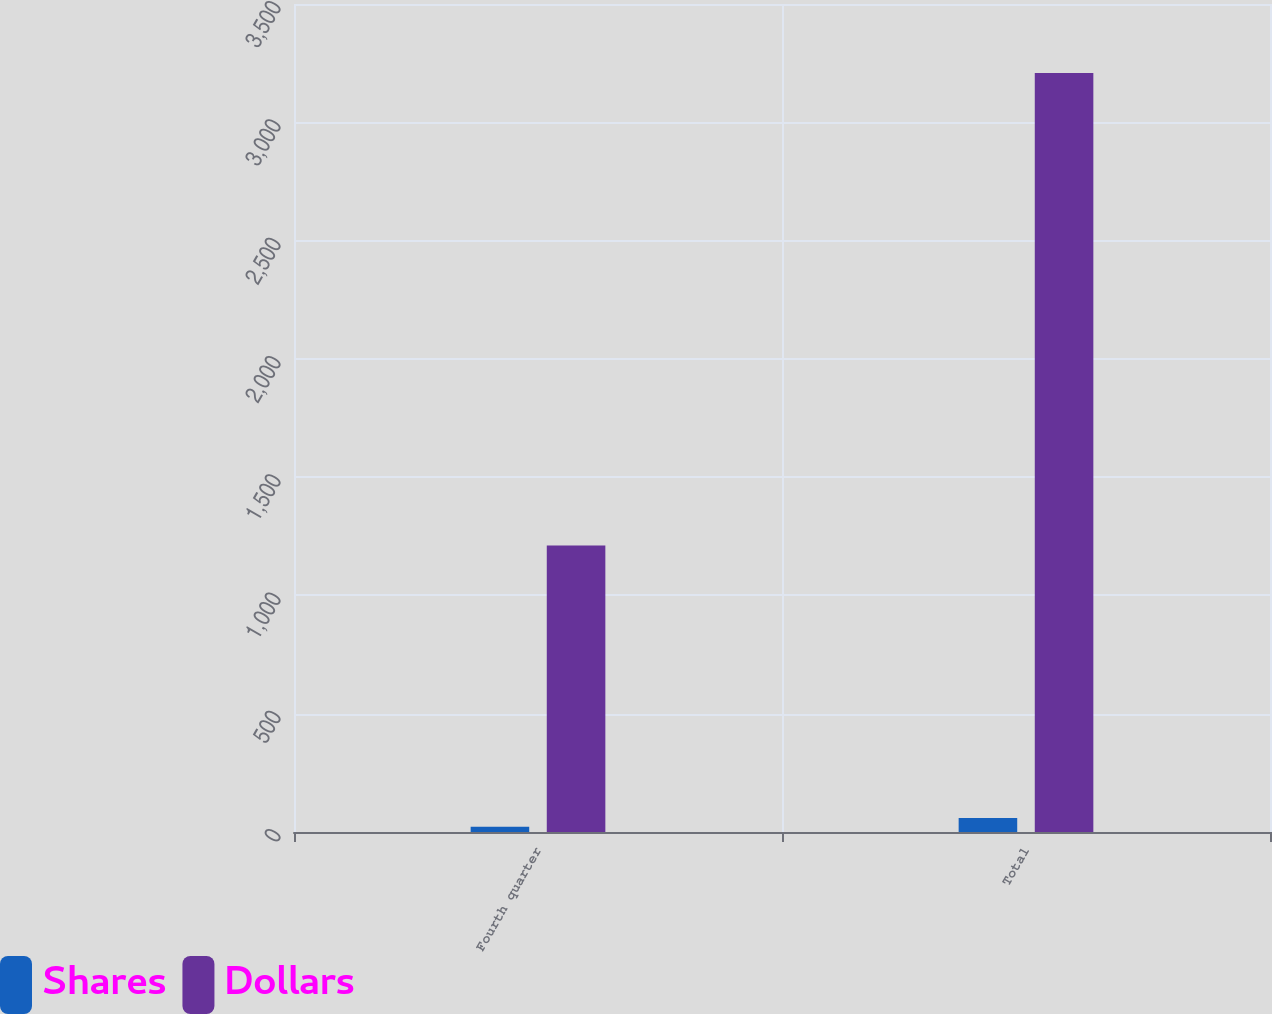Convert chart. <chart><loc_0><loc_0><loc_500><loc_500><stacked_bar_chart><ecel><fcel>Fourth quarter<fcel>Total<nl><fcel>Shares<fcel>21.7<fcel>59.2<nl><fcel>Dollars<fcel>1211<fcel>3208<nl></chart> 